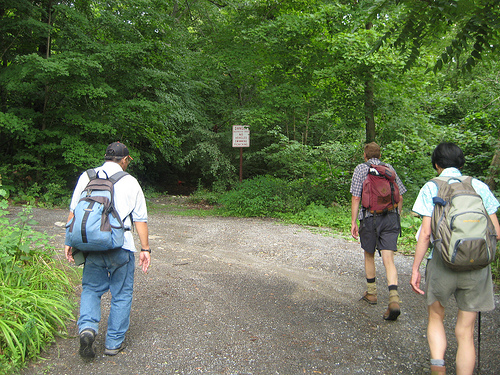<image>
Can you confirm if the bag is on the road? No. The bag is not positioned on the road. They may be near each other, but the bag is not supported by or resting on top of the road. 